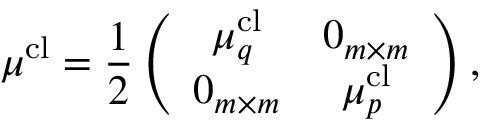Convert formula to latex. <formula><loc_0><loc_0><loc_500><loc_500>\mu ^ { c l } = \frac { 1 } { 2 } \left ( \begin{array} { c c } { \mu _ { q } ^ { c l } } & { 0 _ { m \times m } } \\ { 0 _ { m \times m } } & { \mu _ { p } ^ { c l } } \end{array} \right ) ,</formula> 